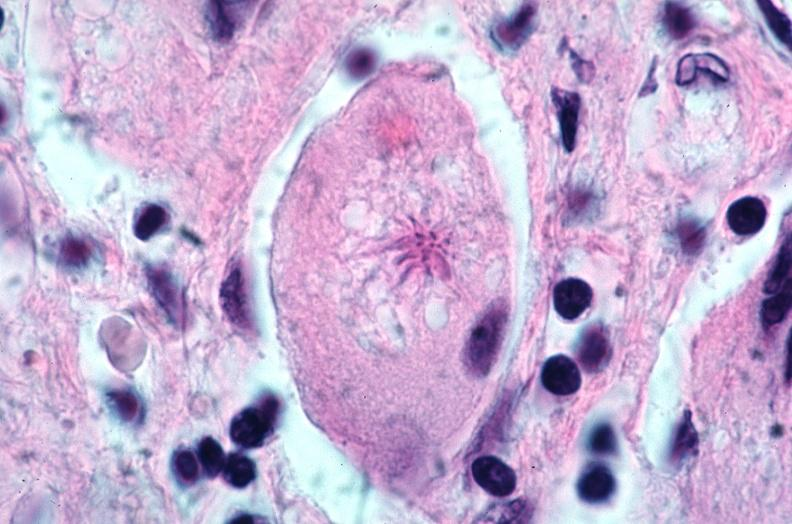where is this?
Answer the question using a single word or phrase. Lung 